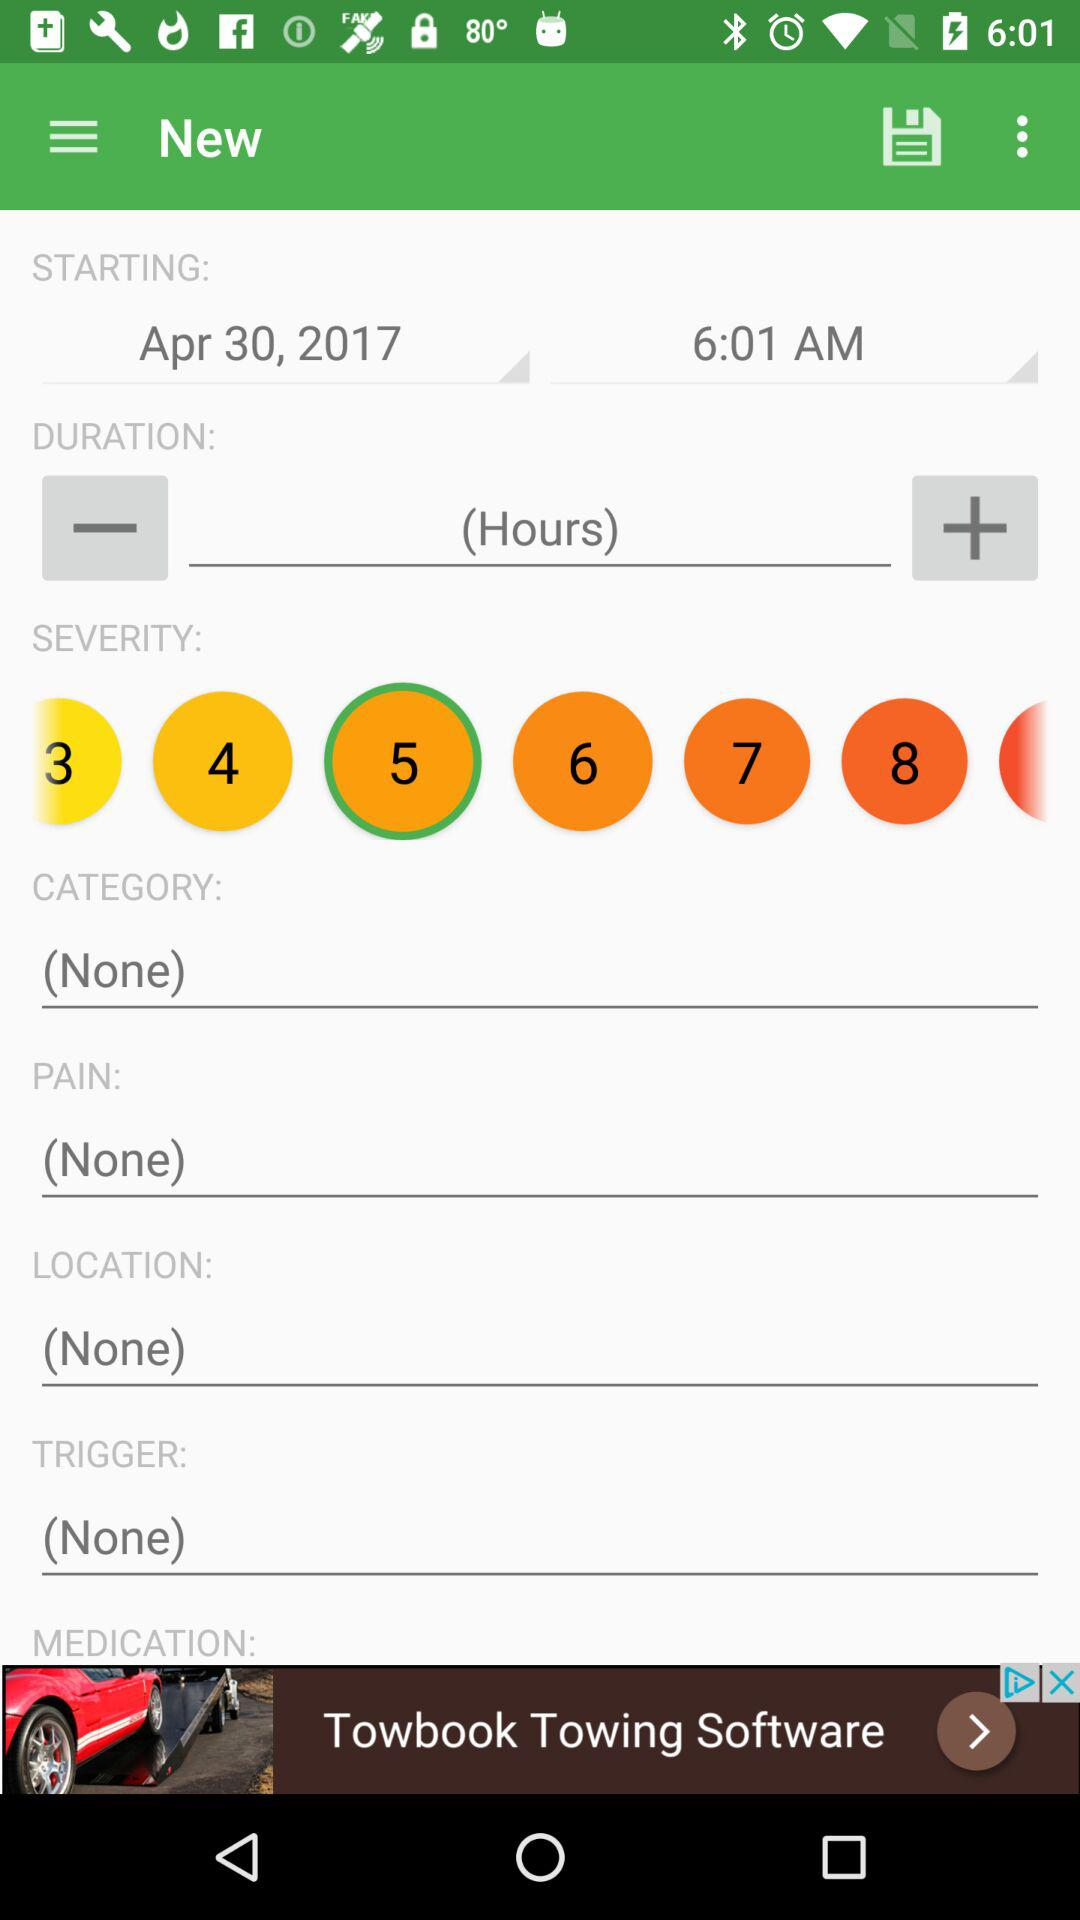Which prescriptions are entered in "MEDICATION"?
When the provided information is insufficient, respond with <no answer>. <no answer> 